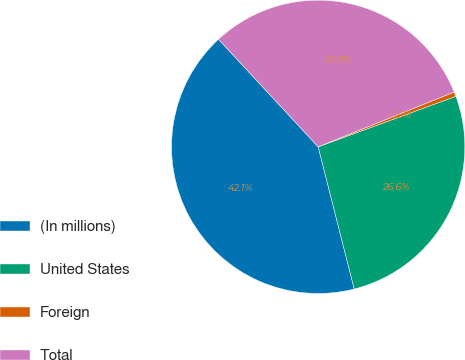Convert chart to OTSL. <chart><loc_0><loc_0><loc_500><loc_500><pie_chart><fcel>(In millions)<fcel>United States<fcel>Foreign<fcel>Total<nl><fcel>42.05%<fcel>26.64%<fcel>0.5%<fcel>30.8%<nl></chart> 